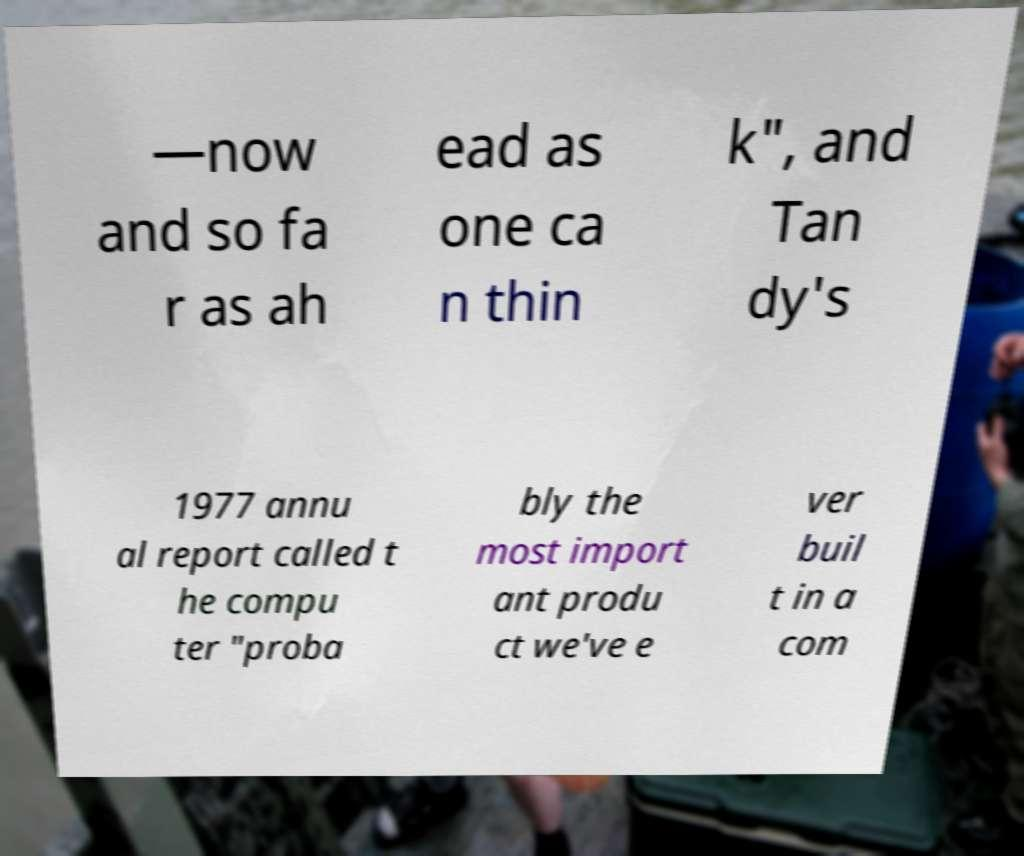Can you accurately transcribe the text from the provided image for me? —now and so fa r as ah ead as one ca n thin k", and Tan dy's 1977 annu al report called t he compu ter "proba bly the most import ant produ ct we've e ver buil t in a com 